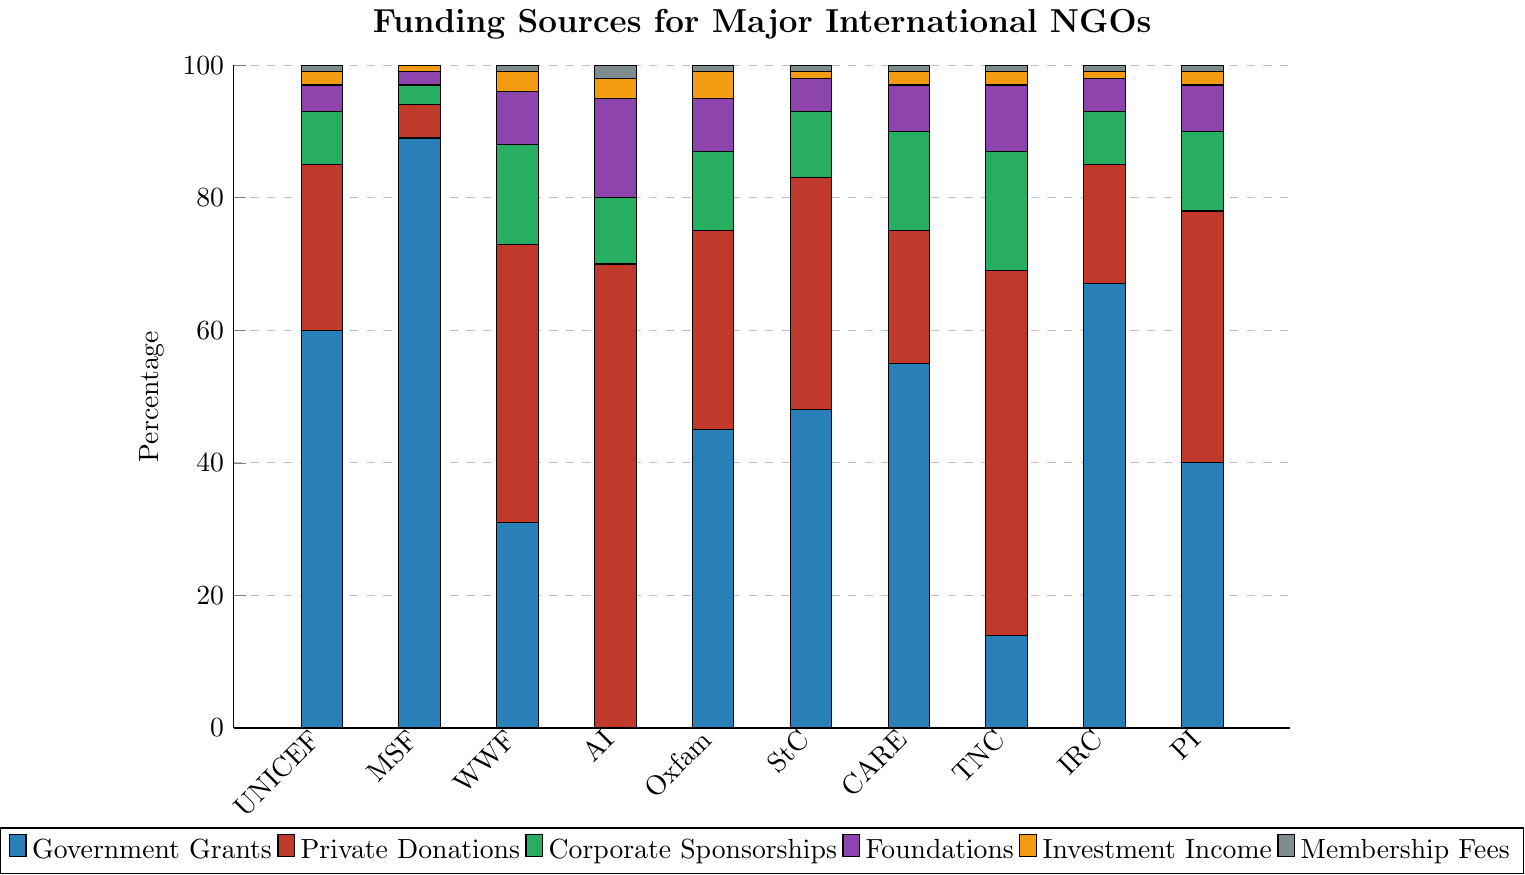Which organization receives the highest percentage of government grants? Look at the tallest blue bar in the chart, representing government grants. The highest blue bar is for Doctors Without Borders (MSF).
Answer: Doctors Without Borders (MSF) Which organization has the smallest percentage of private donations? Look at the red bars in the chart, representing private donations. The smallest percentage of private donations is for Doctors Without Borders (MSF), with a very short red bar.
Answer: Doctors Without Borders (MSF) What is the total percentage of government grants and private donations for UNICEF? Add the percentages of blue and red bars for UNICEF: 60% (government grants) + 25% (private donations) = 85%
Answer: 85% Which organization has the highest percentage from foundations? Look at the purple bars in the chart, representing foundations. The highest purple bar is for Amnesty International (AI).
Answer: Amnesty International (AI) What is the average percentage of investment income across all organizations? Add the percentage values for investment income (yellow bars) from all organizations and divide by the number of organizations: (2 + 1 + 3 + 3 + 4 + 1 + 2 + 2 + 1 + 2)/10 = 21/10 = 2.1%
Answer: 2.1% Which organization has the greatest diversity in funding sources, i.e., well-distributed across different funding categories? Look for bars of various colors of nearly similar heights. World Wildlife Fund (WWF) and Amnesty International (AI) both have more balanced distributions, but World Wildlife Fund (WWF) has a more well-distributed pattern.
Answer: World Wildlife Fund (WWF) Compare the total percentage of membership fees for Plan International and Save the Children. Which one is higher? Compare the gray bars for both Plan International and Save the Children. Both have the same height for membership fees at 1%.
Answer: Equal Which two organizations have the closest percentage of corporate sponsorships? Look at the green bars representing corporate sponsorships. CARE International and World Wildlife Fund (WWF) both have 15%.
Answer: CARE International and World Wildlife Fund (WWF) How many organizations receive more than 50% of their funding from government grants? Count the number of organizations with blue bars exceeding half of the total bar height, i.e., more than 50%. UNICEF, Doctors Without Borders (MSF), and International Rescue Committee receive more than 50%.
Answer: 3 organizations Which organization relies entirely on just one source of funding? Look for an organization with one bar(a single color), indicating 100% funding from that source. None of the bars for any organization show this pattern.
Answer: None 